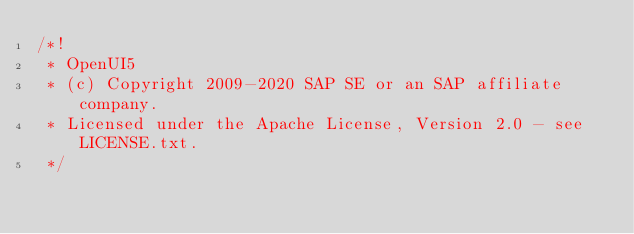<code> <loc_0><loc_0><loc_500><loc_500><_JavaScript_>/*!
 * OpenUI5
 * (c) Copyright 2009-2020 SAP SE or an SAP affiliate company.
 * Licensed under the Apache License, Version 2.0 - see LICENSE.txt.
 */</code> 